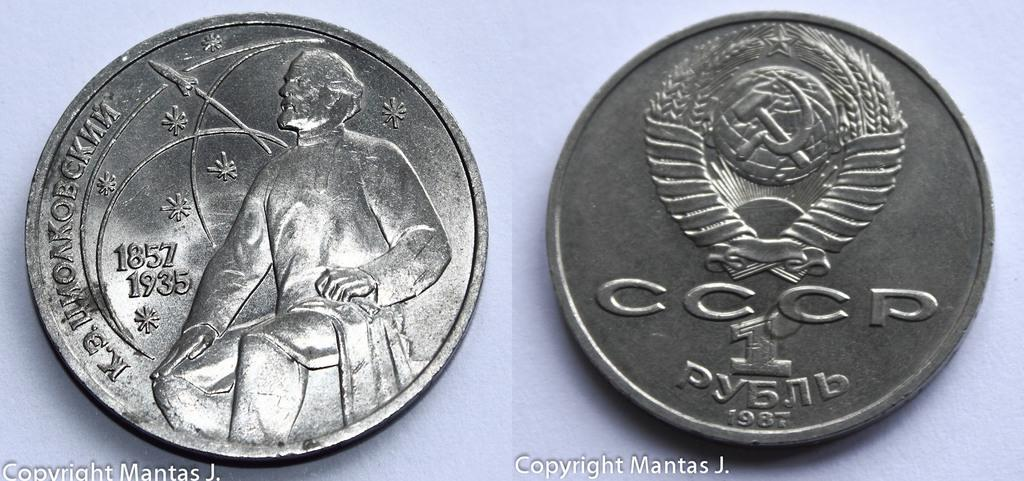<image>
Describe the image concisely. The coin on the right shown was made in 1987. 